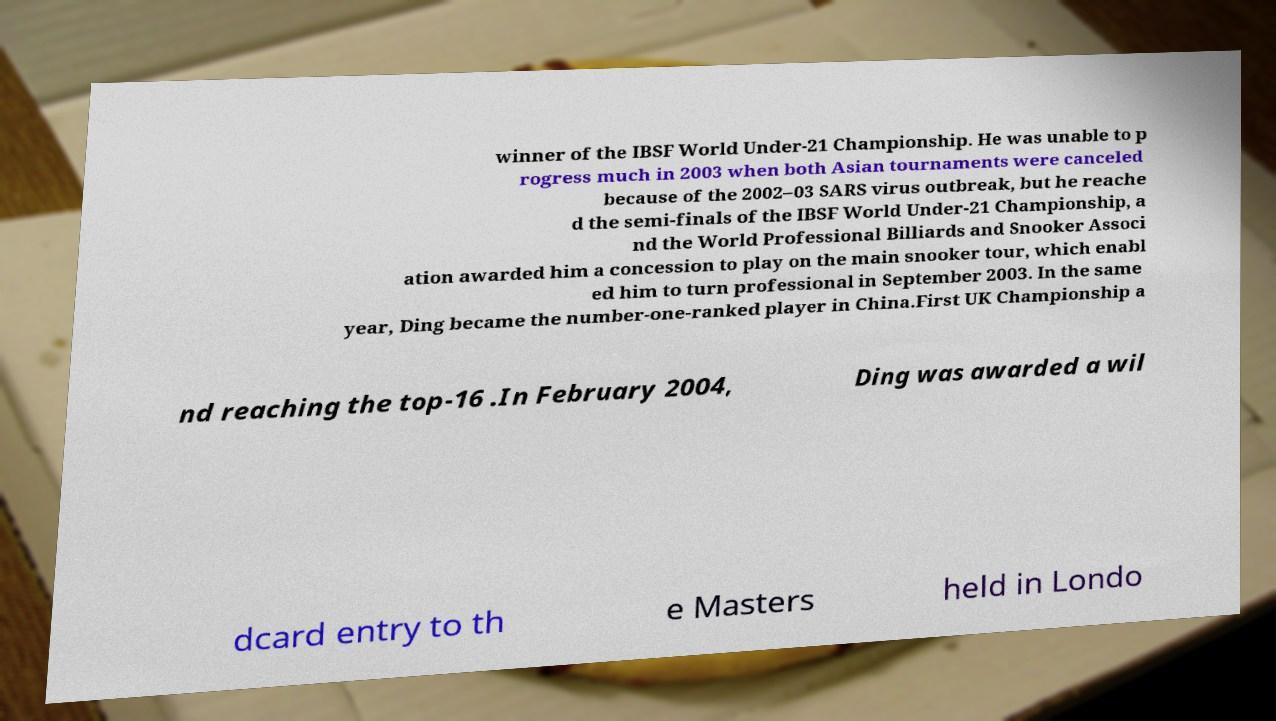Can you read and provide the text displayed in the image?This photo seems to have some interesting text. Can you extract and type it out for me? winner of the IBSF World Under-21 Championship. He was unable to p rogress much in 2003 when both Asian tournaments were canceled because of the 2002–03 SARS virus outbreak, but he reache d the semi-finals of the IBSF World Under-21 Championship, a nd the World Professional Billiards and Snooker Associ ation awarded him a concession to play on the main snooker tour, which enabl ed him to turn professional in September 2003. In the same year, Ding became the number-one-ranked player in China.First UK Championship a nd reaching the top-16 .In February 2004, Ding was awarded a wil dcard entry to th e Masters held in Londo 